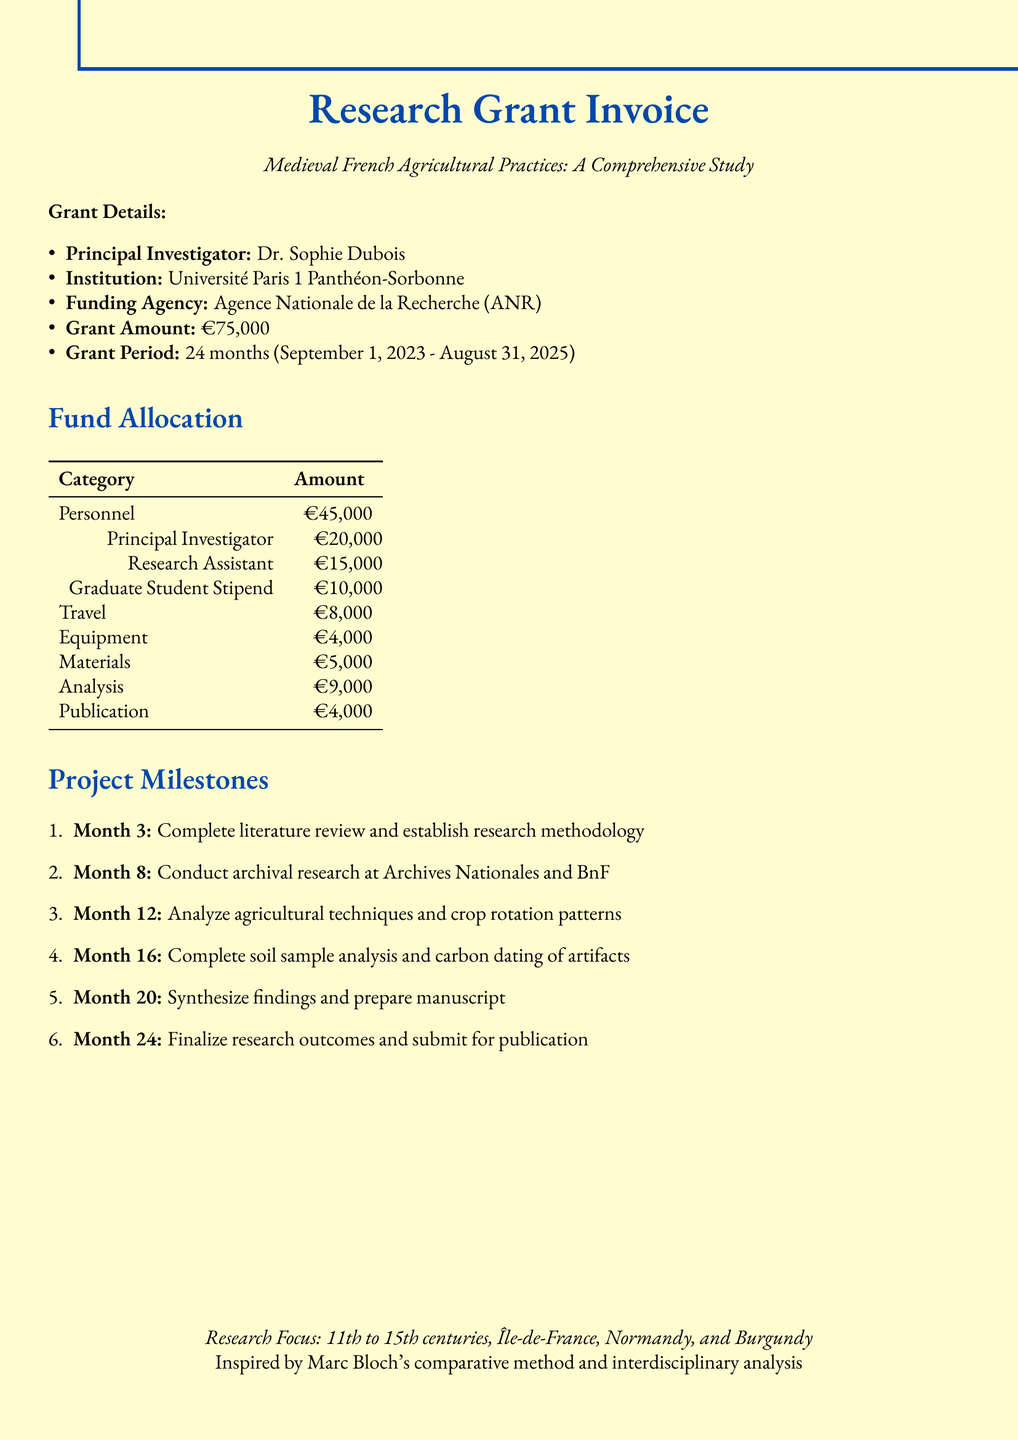What is the title of the research grant? The title of the research grant is stated in the grant details section.
Answer: Medieval French Agricultural Practices: A Comprehensive Study Who is the principal investigator? The document lists the name of the principal investigator under the grant details.
Answer: Dr. Sophie Dubois What is the total grant amount? The total grant amount is mentioned explicitly in the grant details.
Answer: €75,000 How long is the grant period? The duration of the grant period is provided in the grant details.
Answer: 24 months What is the allocation for personnel? The document specifies the allocation for personnel collectively.
Answer: €45,000 Which regions are focused on in the research? The geographical focus is outlined in the research focus section.
Answer: Île-de-France, Normandy, and Burgundy regions What is the deliverable for month 12? The document describes specific deliverables associated with project milestones.
Answer: Draft chapter on medieval French farming practices Which methodological approach is influenced by Marc Bloch? Information on the influence of Marc Bloch is provided in the respective section of the document.
Answer: Comparative method and interdisciplinary analysis What type of report is due in month 24? The document specifies what needs to be submitted at the end of the grant period.
Answer: Final research report and submitted manuscript 